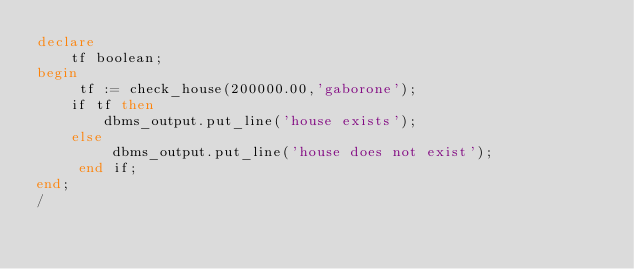Convert code to text. <code><loc_0><loc_0><loc_500><loc_500><_SQL_>declare
    tf boolean;
begin
     tf := check_house(200000.00,'gaborone');
    if tf then
        dbms_output.put_line('house exists');
    else
         dbms_output.put_line('house does not exist');
     end if;
end;
/</code> 